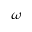<formula> <loc_0><loc_0><loc_500><loc_500>\omega</formula> 